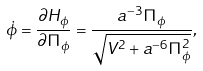Convert formula to latex. <formula><loc_0><loc_0><loc_500><loc_500>\dot { \phi } = \frac { \partial H _ { \phi } } { \partial \Pi _ { \phi } } = \frac { a ^ { - 3 } \Pi _ { \phi } } { \sqrt { V ^ { 2 } + a ^ { - 6 } \Pi _ { \phi } ^ { 2 } } } ,</formula> 